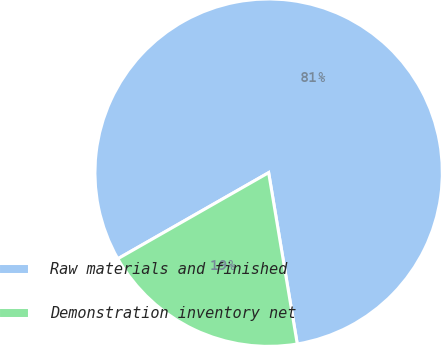<chart> <loc_0><loc_0><loc_500><loc_500><pie_chart><fcel>Raw materials and finished<fcel>Demonstration inventory net<nl><fcel>80.62%<fcel>19.38%<nl></chart> 